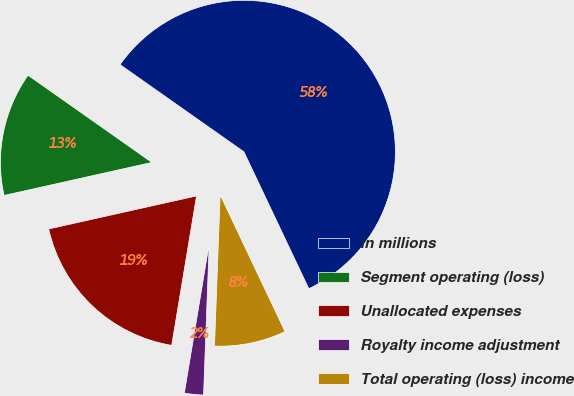Convert chart. <chart><loc_0><loc_0><loc_500><loc_500><pie_chart><fcel>in millions<fcel>Segment operating (loss)<fcel>Unallocated expenses<fcel>Royalty income adjustment<fcel>Total operating (loss) income<nl><fcel>58.19%<fcel>13.26%<fcel>18.88%<fcel>2.03%<fcel>7.64%<nl></chart> 